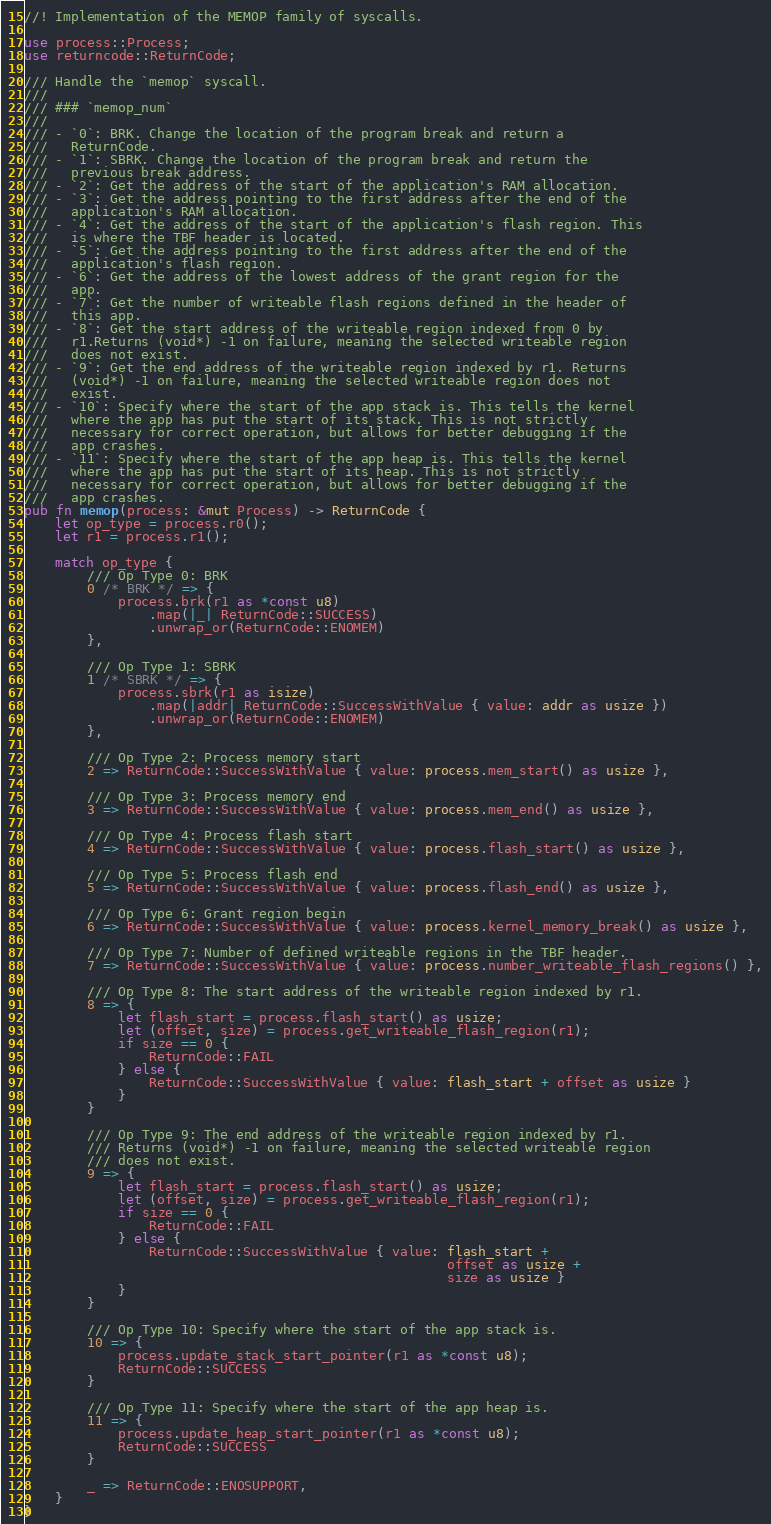<code> <loc_0><loc_0><loc_500><loc_500><_Rust_>//! Implementation of the MEMOP family of syscalls.

use process::Process;
use returncode::ReturnCode;

/// Handle the `memop` syscall.
///
/// ### `memop_num`
///
/// - `0`: BRK. Change the location of the program break and return a
///   ReturnCode.
/// - `1`: SBRK. Change the location of the program break and return the
///   previous break address.
/// - `2`: Get the address of the start of the application's RAM allocation.
/// - `3`: Get the address pointing to the first address after the end of the
///   application's RAM allocation.
/// - `4`: Get the address of the start of the application's flash region. This
///   is where the TBF header is located.
/// - `5`: Get the address pointing to the first address after the end of the
///   application's flash region.
/// - `6`: Get the address of the lowest address of the grant region for the
///   app.
/// - `7`: Get the number of writeable flash regions defined in the header of
///   this app.
/// - `8`: Get the start address of the writeable region indexed from 0 by
///   r1.Returns (void*) -1 on failure, meaning the selected writeable region
///   does not exist.
/// - `9`: Get the end address of the writeable region indexed by r1. Returns
///   (void*) -1 on failure, meaning the selected writeable region does not
///   exist.
/// - `10`: Specify where the start of the app stack is. This tells the kernel
///   where the app has put the start of its stack. This is not strictly
///   necessary for correct operation, but allows for better debugging if the
///   app crashes.
/// - `11`: Specify where the start of the app heap is. This tells the kernel
///   where the app has put the start of its heap. This is not strictly
///   necessary for correct operation, but allows for better debugging if the
///   app crashes.
pub fn memop(process: &mut Process) -> ReturnCode {
    let op_type = process.r0();
    let r1 = process.r1();

    match op_type {
        /// Op Type 0: BRK
        0 /* BRK */ => {
            process.brk(r1 as *const u8)
                .map(|_| ReturnCode::SUCCESS)
                .unwrap_or(ReturnCode::ENOMEM)
        },

        /// Op Type 1: SBRK
        1 /* SBRK */ => {
            process.sbrk(r1 as isize)
                .map(|addr| ReturnCode::SuccessWithValue { value: addr as usize })
                .unwrap_or(ReturnCode::ENOMEM)
        },

        /// Op Type 2: Process memory start
        2 => ReturnCode::SuccessWithValue { value: process.mem_start() as usize },

        /// Op Type 3: Process memory end
        3 => ReturnCode::SuccessWithValue { value: process.mem_end() as usize },

        /// Op Type 4: Process flash start
        4 => ReturnCode::SuccessWithValue { value: process.flash_start() as usize },

        /// Op Type 5: Process flash end
        5 => ReturnCode::SuccessWithValue { value: process.flash_end() as usize },

        /// Op Type 6: Grant region begin
        6 => ReturnCode::SuccessWithValue { value: process.kernel_memory_break() as usize },

        /// Op Type 7: Number of defined writeable regions in the TBF header.
        7 => ReturnCode::SuccessWithValue { value: process.number_writeable_flash_regions() },

        /// Op Type 8: The start address of the writeable region indexed by r1.
        8 => {
            let flash_start = process.flash_start() as usize;
            let (offset, size) = process.get_writeable_flash_region(r1);
            if size == 0 {
                ReturnCode::FAIL
            } else {
                ReturnCode::SuccessWithValue { value: flash_start + offset as usize }
            }
        }

        /// Op Type 9: The end address of the writeable region indexed by r1.
        /// Returns (void*) -1 on failure, meaning the selected writeable region
        /// does not exist.
        9 => {
            let flash_start = process.flash_start() as usize;
            let (offset, size) = process.get_writeable_flash_region(r1);
            if size == 0 {
                ReturnCode::FAIL
            } else {
                ReturnCode::SuccessWithValue { value: flash_start +
                                                      offset as usize +
                                                      size as usize }
            }
        }

        /// Op Type 10: Specify where the start of the app stack is.
        10 => {
            process.update_stack_start_pointer(r1 as *const u8);
            ReturnCode::SUCCESS
        }

        /// Op Type 11: Specify where the start of the app heap is.
        11 => {
            process.update_heap_start_pointer(r1 as *const u8);
            ReturnCode::SUCCESS
        }

        _ => ReturnCode::ENOSUPPORT,
    }
}
</code> 